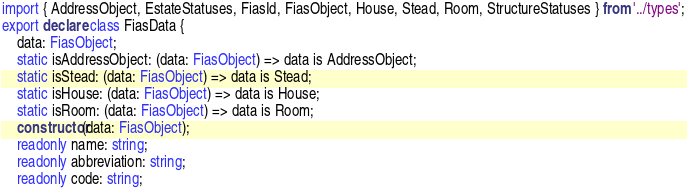<code> <loc_0><loc_0><loc_500><loc_500><_TypeScript_>import { AddressObject, EstateStatuses, FiasId, FiasObject, House, Stead, Room, StructureStatuses } from '../types';
export declare class FiasData {
    data: FiasObject;
    static isAddressObject: (data: FiasObject) => data is AddressObject;
    static isStead: (data: FiasObject) => data is Stead;
    static isHouse: (data: FiasObject) => data is House;
    static isRoom: (data: FiasObject) => data is Room;
    constructor(data: FiasObject);
    readonly name: string;
    readonly abbreviation: string;
    readonly code: string;</code> 